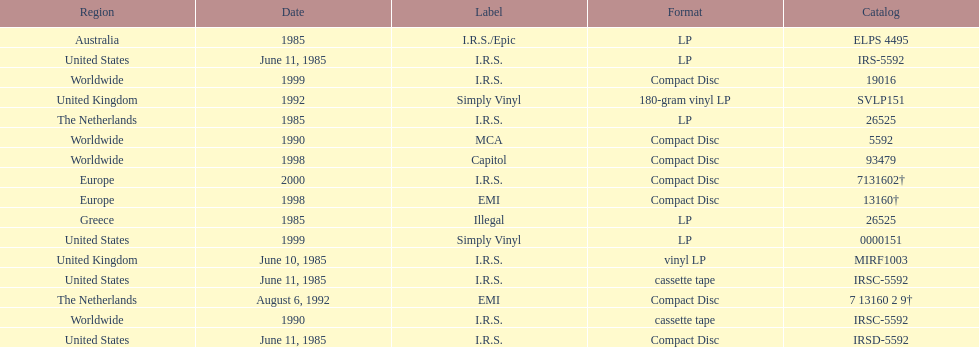Name at least two labels that released the group's albums. I.R.S., Illegal. 